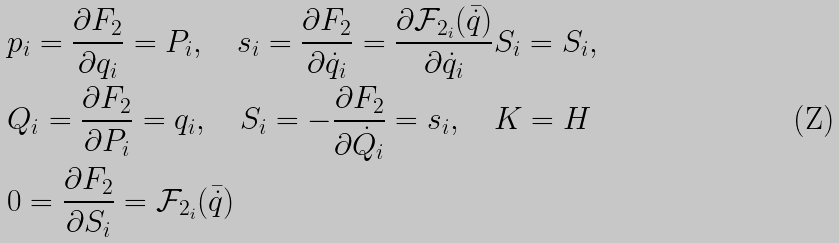Convert formula to latex. <formula><loc_0><loc_0><loc_500><loc_500>& p _ { i } = \frac { \partial F _ { 2 } } { \partial q _ { i } } = P _ { i } , \quad s _ { i } = \frac { \partial F _ { 2 } } { \partial \dot { q } _ { i } } = \frac { \partial \mathcal { F } _ { 2 _ { i } } ( \bar { \dot { q } } ) } { \partial \dot { q } _ { i } } S _ { i } = S _ { i } , \\ & Q _ { i } = \frac { \partial F _ { 2 } } { \partial P _ { i } } = q _ { i } , \quad S _ { i } = - \frac { \partial F _ { 2 } } { \partial \dot { Q } _ { i } } = s _ { i } , \quad K = H \\ & 0 = \frac { \partial F _ { 2 } } { \partial S _ { i } } = \mathcal { F } _ { 2 _ { i } } ( \bar { \dot { q } } )</formula> 